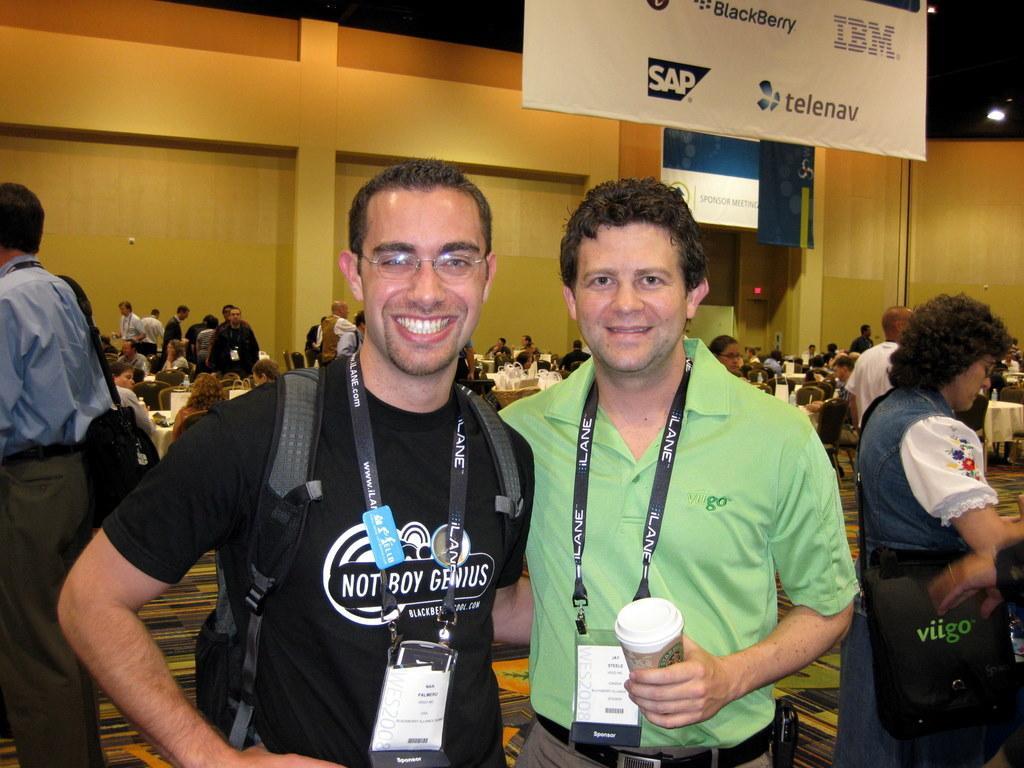Could you give a brief overview of what you see in this image? At the bottom of this image, there are two persons, smiling, wearing badges and standing. One of them is holding a cup. On the left side, there is a person in a blue color shirt, standing. On the right side, there is a woman wearing a bag and standing. In the background, there are persons, some of them are sitting in front of the tables on which there are some objects arranged, there are banners and lights arranged and there is a wall. 